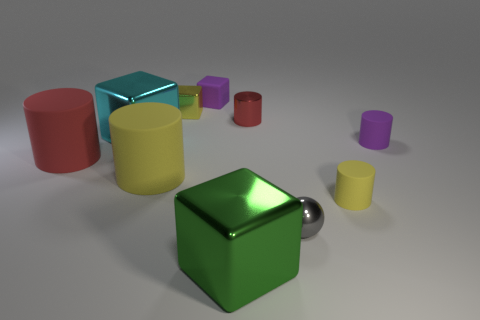Subtract all matte cubes. How many cubes are left? 3 Subtract all blue spheres. How many red cylinders are left? 2 Subtract all purple cubes. How many cubes are left? 3 Subtract 3 cylinders. How many cylinders are left? 2 Subtract all blocks. How many objects are left? 6 Add 5 big blue metallic objects. How many big blue metallic objects exist? 5 Subtract 0 blue cylinders. How many objects are left? 10 Subtract all blue cylinders. Subtract all cyan balls. How many cylinders are left? 5 Subtract all green metal things. Subtract all purple rubber cylinders. How many objects are left? 8 Add 1 gray balls. How many gray balls are left? 2 